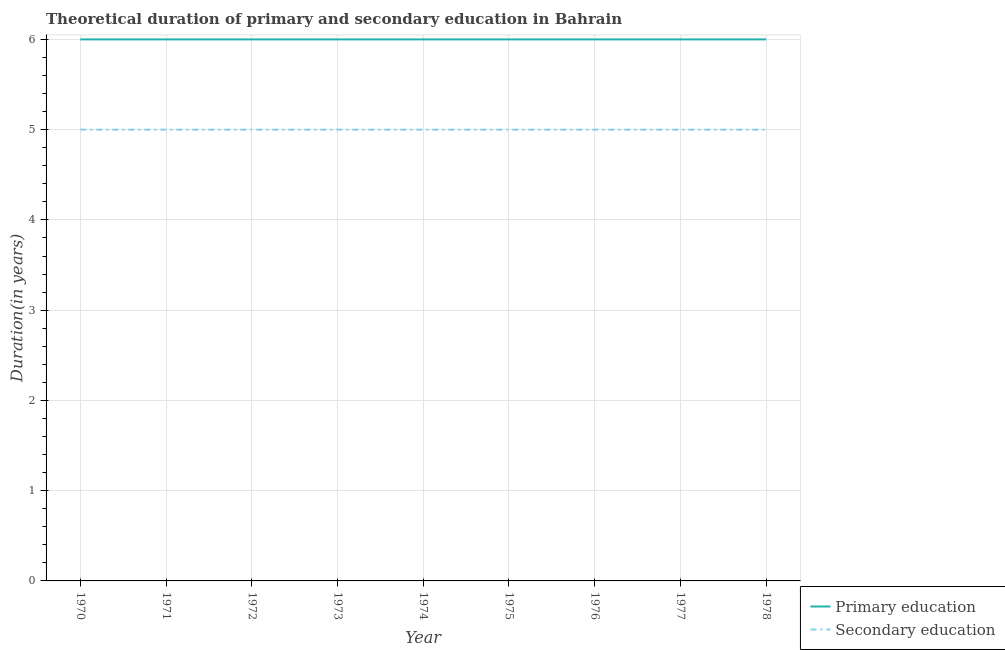Across all years, what is the maximum duration of secondary education?
Make the answer very short. 5. Across all years, what is the minimum duration of primary education?
Your answer should be compact. 6. In which year was the duration of primary education minimum?
Keep it short and to the point. 1970. What is the total duration of secondary education in the graph?
Offer a very short reply. 45. What is the difference between the duration of primary education in 1971 and that in 1975?
Offer a terse response. 0. What is the difference between the duration of primary education in 1978 and the duration of secondary education in 1976?
Your response must be concise. 1. What is the average duration of secondary education per year?
Keep it short and to the point. 5. In the year 1973, what is the difference between the duration of primary education and duration of secondary education?
Your answer should be very brief. 1. In how many years, is the duration of secondary education greater than 0.2 years?
Ensure brevity in your answer.  9. What is the ratio of the duration of secondary education in 1971 to that in 1973?
Offer a very short reply. 1. Is the difference between the duration of primary education in 1970 and 1976 greater than the difference between the duration of secondary education in 1970 and 1976?
Provide a succinct answer. No. What is the difference between the highest and the lowest duration of secondary education?
Provide a succinct answer. 0. Does the duration of secondary education monotonically increase over the years?
Ensure brevity in your answer.  No. Is the duration of secondary education strictly less than the duration of primary education over the years?
Give a very brief answer. Yes. How many lines are there?
Make the answer very short. 2. What is the difference between two consecutive major ticks on the Y-axis?
Keep it short and to the point. 1. Are the values on the major ticks of Y-axis written in scientific E-notation?
Provide a succinct answer. No. Where does the legend appear in the graph?
Your answer should be very brief. Bottom right. How are the legend labels stacked?
Ensure brevity in your answer.  Vertical. What is the title of the graph?
Ensure brevity in your answer.  Theoretical duration of primary and secondary education in Bahrain. Does "By country of origin" appear as one of the legend labels in the graph?
Offer a very short reply. No. What is the label or title of the X-axis?
Keep it short and to the point. Year. What is the label or title of the Y-axis?
Keep it short and to the point. Duration(in years). What is the Duration(in years) in Primary education in 1970?
Provide a short and direct response. 6. What is the Duration(in years) in Secondary education in 1970?
Provide a succinct answer. 5. What is the Duration(in years) of Secondary education in 1974?
Offer a very short reply. 5. What is the Duration(in years) of Primary education in 1977?
Your answer should be compact. 6. What is the Duration(in years) in Secondary education in 1978?
Provide a succinct answer. 5. Across all years, what is the maximum Duration(in years) in Primary education?
Keep it short and to the point. 6. Across all years, what is the minimum Duration(in years) of Primary education?
Offer a terse response. 6. Across all years, what is the minimum Duration(in years) of Secondary education?
Your answer should be compact. 5. What is the total Duration(in years) of Primary education in the graph?
Keep it short and to the point. 54. What is the total Duration(in years) in Secondary education in the graph?
Make the answer very short. 45. What is the difference between the Duration(in years) in Secondary education in 1970 and that in 1971?
Ensure brevity in your answer.  0. What is the difference between the Duration(in years) of Secondary education in 1970 and that in 1973?
Provide a succinct answer. 0. What is the difference between the Duration(in years) of Primary education in 1970 and that in 1974?
Provide a short and direct response. 0. What is the difference between the Duration(in years) of Secondary education in 1970 and that in 1974?
Offer a terse response. 0. What is the difference between the Duration(in years) in Primary education in 1970 and that in 1976?
Offer a terse response. 0. What is the difference between the Duration(in years) in Secondary education in 1970 and that in 1976?
Give a very brief answer. 0. What is the difference between the Duration(in years) in Primary education in 1970 and that in 1977?
Provide a succinct answer. 0. What is the difference between the Duration(in years) of Secondary education in 1970 and that in 1978?
Your answer should be very brief. 0. What is the difference between the Duration(in years) of Secondary education in 1971 and that in 1972?
Your response must be concise. 0. What is the difference between the Duration(in years) of Primary education in 1971 and that in 1973?
Offer a very short reply. 0. What is the difference between the Duration(in years) in Primary education in 1971 and that in 1974?
Your answer should be compact. 0. What is the difference between the Duration(in years) in Secondary education in 1971 and that in 1974?
Your response must be concise. 0. What is the difference between the Duration(in years) of Secondary education in 1971 and that in 1975?
Your answer should be compact. 0. What is the difference between the Duration(in years) of Primary education in 1971 and that in 1976?
Your answer should be very brief. 0. What is the difference between the Duration(in years) in Secondary education in 1971 and that in 1977?
Keep it short and to the point. 0. What is the difference between the Duration(in years) in Secondary education in 1971 and that in 1978?
Your response must be concise. 0. What is the difference between the Duration(in years) of Primary education in 1972 and that in 1973?
Your answer should be compact. 0. What is the difference between the Duration(in years) of Secondary education in 1972 and that in 1973?
Make the answer very short. 0. What is the difference between the Duration(in years) of Secondary education in 1972 and that in 1975?
Your answer should be very brief. 0. What is the difference between the Duration(in years) in Primary education in 1972 and that in 1976?
Provide a short and direct response. 0. What is the difference between the Duration(in years) in Secondary education in 1972 and that in 1977?
Your answer should be compact. 0. What is the difference between the Duration(in years) of Primary education in 1972 and that in 1978?
Ensure brevity in your answer.  0. What is the difference between the Duration(in years) in Secondary education in 1972 and that in 1978?
Provide a short and direct response. 0. What is the difference between the Duration(in years) of Primary education in 1973 and that in 1974?
Your answer should be compact. 0. What is the difference between the Duration(in years) of Secondary education in 1973 and that in 1974?
Give a very brief answer. 0. What is the difference between the Duration(in years) of Primary education in 1973 and that in 1975?
Offer a very short reply. 0. What is the difference between the Duration(in years) of Primary education in 1973 and that in 1976?
Provide a short and direct response. 0. What is the difference between the Duration(in years) in Primary education in 1973 and that in 1977?
Give a very brief answer. 0. What is the difference between the Duration(in years) of Secondary education in 1973 and that in 1977?
Make the answer very short. 0. What is the difference between the Duration(in years) of Secondary education in 1973 and that in 1978?
Keep it short and to the point. 0. What is the difference between the Duration(in years) in Primary education in 1974 and that in 1975?
Keep it short and to the point. 0. What is the difference between the Duration(in years) in Secondary education in 1974 and that in 1977?
Offer a very short reply. 0. What is the difference between the Duration(in years) in Primary education in 1975 and that in 1976?
Your answer should be compact. 0. What is the difference between the Duration(in years) in Secondary education in 1975 and that in 1976?
Offer a terse response. 0. What is the difference between the Duration(in years) of Primary education in 1975 and that in 1977?
Offer a terse response. 0. What is the difference between the Duration(in years) of Secondary education in 1975 and that in 1977?
Offer a very short reply. 0. What is the difference between the Duration(in years) of Primary education in 1976 and that in 1977?
Offer a terse response. 0. What is the difference between the Duration(in years) of Secondary education in 1976 and that in 1977?
Provide a succinct answer. 0. What is the difference between the Duration(in years) of Primary education in 1976 and that in 1978?
Keep it short and to the point. 0. What is the difference between the Duration(in years) in Secondary education in 1977 and that in 1978?
Provide a succinct answer. 0. What is the difference between the Duration(in years) of Primary education in 1970 and the Duration(in years) of Secondary education in 1971?
Keep it short and to the point. 1. What is the difference between the Duration(in years) in Primary education in 1970 and the Duration(in years) in Secondary education in 1972?
Offer a terse response. 1. What is the difference between the Duration(in years) of Primary education in 1970 and the Duration(in years) of Secondary education in 1973?
Give a very brief answer. 1. What is the difference between the Duration(in years) of Primary education in 1970 and the Duration(in years) of Secondary education in 1976?
Ensure brevity in your answer.  1. What is the difference between the Duration(in years) of Primary education in 1970 and the Duration(in years) of Secondary education in 1977?
Your answer should be compact. 1. What is the difference between the Duration(in years) of Primary education in 1971 and the Duration(in years) of Secondary education in 1972?
Offer a terse response. 1. What is the difference between the Duration(in years) in Primary education in 1971 and the Duration(in years) in Secondary education in 1974?
Provide a short and direct response. 1. What is the difference between the Duration(in years) of Primary education in 1971 and the Duration(in years) of Secondary education in 1977?
Your response must be concise. 1. What is the difference between the Duration(in years) of Primary education in 1971 and the Duration(in years) of Secondary education in 1978?
Offer a terse response. 1. What is the difference between the Duration(in years) in Primary education in 1972 and the Duration(in years) in Secondary education in 1974?
Your answer should be very brief. 1. What is the difference between the Duration(in years) of Primary education in 1972 and the Duration(in years) of Secondary education in 1977?
Your answer should be very brief. 1. What is the difference between the Duration(in years) of Primary education in 1973 and the Duration(in years) of Secondary education in 1974?
Your answer should be very brief. 1. What is the difference between the Duration(in years) in Primary education in 1973 and the Duration(in years) in Secondary education in 1976?
Offer a very short reply. 1. What is the difference between the Duration(in years) of Primary education in 1974 and the Duration(in years) of Secondary education in 1977?
Your answer should be very brief. 1. What is the difference between the Duration(in years) of Primary education in 1974 and the Duration(in years) of Secondary education in 1978?
Your answer should be compact. 1. What is the difference between the Duration(in years) in Primary education in 1975 and the Duration(in years) in Secondary education in 1977?
Offer a very short reply. 1. What is the difference between the Duration(in years) of Primary education in 1976 and the Duration(in years) of Secondary education in 1977?
Offer a terse response. 1. What is the difference between the Duration(in years) in Primary education in 1976 and the Duration(in years) in Secondary education in 1978?
Keep it short and to the point. 1. What is the difference between the Duration(in years) of Primary education in 1977 and the Duration(in years) of Secondary education in 1978?
Give a very brief answer. 1. What is the average Duration(in years) in Secondary education per year?
Your answer should be compact. 5. In the year 1973, what is the difference between the Duration(in years) of Primary education and Duration(in years) of Secondary education?
Provide a succinct answer. 1. In the year 1974, what is the difference between the Duration(in years) in Primary education and Duration(in years) in Secondary education?
Give a very brief answer. 1. In the year 1975, what is the difference between the Duration(in years) in Primary education and Duration(in years) in Secondary education?
Your response must be concise. 1. In the year 1978, what is the difference between the Duration(in years) of Primary education and Duration(in years) of Secondary education?
Make the answer very short. 1. What is the ratio of the Duration(in years) in Primary education in 1970 to that in 1971?
Provide a short and direct response. 1. What is the ratio of the Duration(in years) of Primary education in 1970 to that in 1972?
Your answer should be very brief. 1. What is the ratio of the Duration(in years) of Primary education in 1970 to that in 1976?
Provide a short and direct response. 1. What is the ratio of the Duration(in years) in Secondary education in 1970 to that in 1977?
Your answer should be very brief. 1. What is the ratio of the Duration(in years) of Primary education in 1970 to that in 1978?
Offer a very short reply. 1. What is the ratio of the Duration(in years) of Secondary education in 1970 to that in 1978?
Your response must be concise. 1. What is the ratio of the Duration(in years) in Secondary education in 1971 to that in 1972?
Your response must be concise. 1. What is the ratio of the Duration(in years) in Secondary education in 1971 to that in 1973?
Provide a succinct answer. 1. What is the ratio of the Duration(in years) of Primary education in 1971 to that in 1974?
Your answer should be very brief. 1. What is the ratio of the Duration(in years) of Secondary education in 1971 to that in 1974?
Your response must be concise. 1. What is the ratio of the Duration(in years) in Secondary education in 1971 to that in 1975?
Your answer should be very brief. 1. What is the ratio of the Duration(in years) of Primary education in 1971 to that in 1976?
Your answer should be compact. 1. What is the ratio of the Duration(in years) of Secondary education in 1971 to that in 1977?
Offer a very short reply. 1. What is the ratio of the Duration(in years) in Primary education in 1971 to that in 1978?
Provide a short and direct response. 1. What is the ratio of the Duration(in years) of Primary education in 1972 to that in 1973?
Provide a succinct answer. 1. What is the ratio of the Duration(in years) of Primary education in 1972 to that in 1974?
Provide a short and direct response. 1. What is the ratio of the Duration(in years) in Secondary education in 1972 to that in 1974?
Ensure brevity in your answer.  1. What is the ratio of the Duration(in years) in Secondary education in 1972 to that in 1975?
Your response must be concise. 1. What is the ratio of the Duration(in years) in Primary education in 1972 to that in 1976?
Provide a short and direct response. 1. What is the ratio of the Duration(in years) of Secondary education in 1972 to that in 1976?
Offer a very short reply. 1. What is the ratio of the Duration(in years) of Primary education in 1972 to that in 1978?
Provide a short and direct response. 1. What is the ratio of the Duration(in years) in Secondary education in 1972 to that in 1978?
Provide a succinct answer. 1. What is the ratio of the Duration(in years) in Primary education in 1973 to that in 1974?
Your response must be concise. 1. What is the ratio of the Duration(in years) in Primary education in 1973 to that in 1975?
Give a very brief answer. 1. What is the ratio of the Duration(in years) in Secondary education in 1973 to that in 1975?
Make the answer very short. 1. What is the ratio of the Duration(in years) of Secondary education in 1973 to that in 1976?
Provide a succinct answer. 1. What is the ratio of the Duration(in years) in Primary education in 1974 to that in 1975?
Give a very brief answer. 1. What is the ratio of the Duration(in years) in Secondary education in 1974 to that in 1976?
Offer a terse response. 1. What is the ratio of the Duration(in years) of Primary education in 1974 to that in 1977?
Your answer should be compact. 1. What is the ratio of the Duration(in years) of Secondary education in 1974 to that in 1977?
Make the answer very short. 1. What is the ratio of the Duration(in years) in Primary education in 1975 to that in 1976?
Give a very brief answer. 1. What is the ratio of the Duration(in years) in Secondary education in 1975 to that in 1976?
Provide a short and direct response. 1. What is the ratio of the Duration(in years) in Secondary education in 1975 to that in 1977?
Provide a short and direct response. 1. What is the ratio of the Duration(in years) of Primary education in 1975 to that in 1978?
Give a very brief answer. 1. What is the ratio of the Duration(in years) in Secondary education in 1975 to that in 1978?
Your answer should be compact. 1. What is the ratio of the Duration(in years) of Primary education in 1976 to that in 1978?
Make the answer very short. 1. What is the ratio of the Duration(in years) in Secondary education in 1976 to that in 1978?
Your answer should be compact. 1. What is the difference between the highest and the lowest Duration(in years) in Secondary education?
Make the answer very short. 0. 